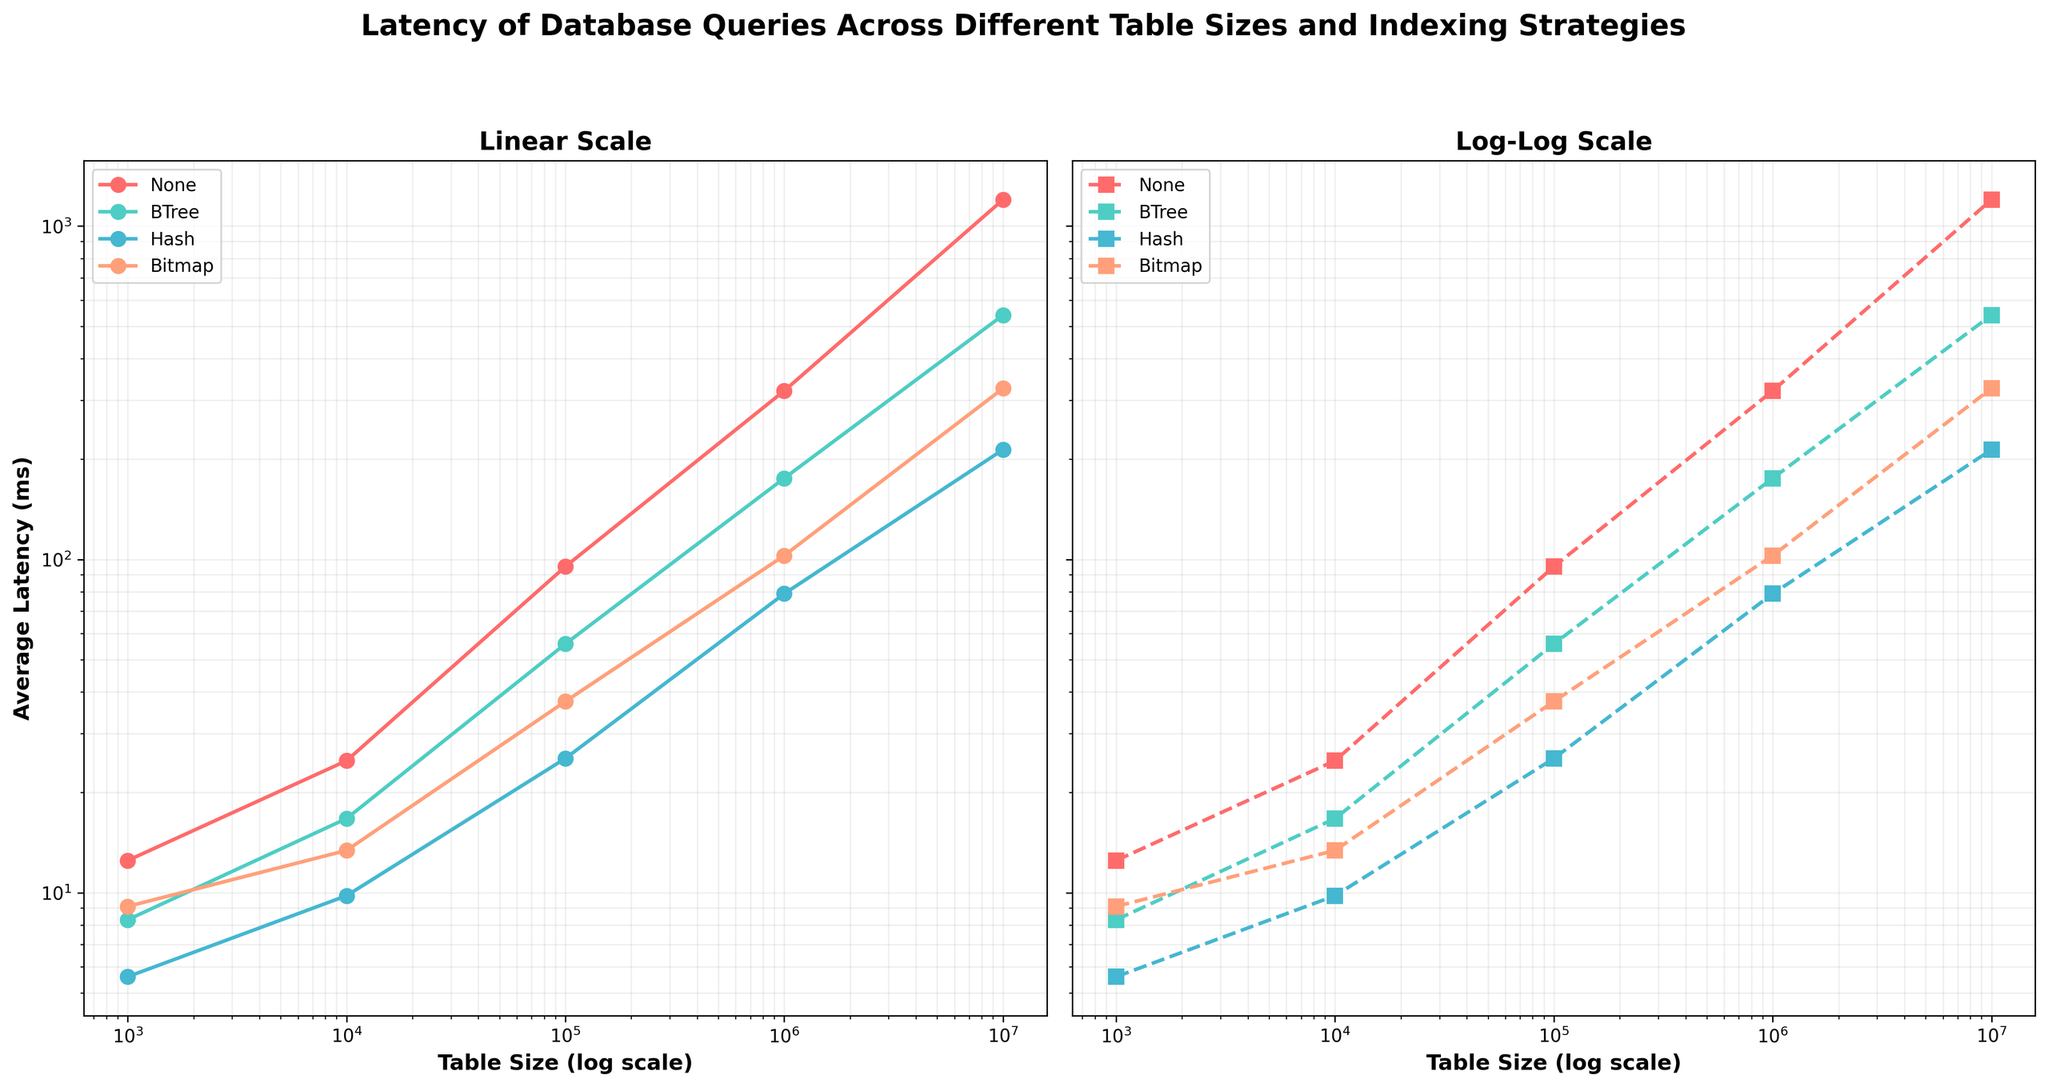What are the indexing strategies used in the figure? The figure's legend in both subplots lists the indexing strategies. These are None, BTree, Hash, and Bitmap.
Answer: None, BTree, Hash, Bitmap How does the latency of queries without indexing change as table size increases? The first subplot shows that the latency of queries with "None" indexing increases significantly as table size grows. It starts from 12.5 ms for table size 1000 and reaches 1200.4 ms for table size 10000000.
Answer: Increases significantly Which indexing strategy has the lowest latency for the largest table size? In the second subplot with log-log scale, the "Hash" indexing strategy shows the lowest latency for the largest table size (10,000,000) corresponding to an average latency of 213.5 ms.
Answer: Hash What is the difference in latency between BTree and Hash indexing strategies for a table size of 1,000,000? From the plots, the latency for BTree at 1,000,000 is 175.2 ms and for Hash is 78.9 ms. The difference is 175.2 - 78.9 = 96.3 ms.
Answer: 96.3 ms Which indexing strategy consistently shows a lower latency compared to Bitmap indexing for all table sizes? By comparing each point across the table sizes, "Hash" indexing consistently shows lower latency compared to "Bitmap" indexing across all table sizes.
Answer: Hash Is there a noticeable difference in trends between linear and log-log scale plots? Yes, while the linear scale shows the absolute value changes, the log-log scale provides a clearer view of the proportional differences and exponential growth patterns. Overall, the relative trends remain consistent, but the log-log scale elucidates exponential patterns.
Answer: Yes For a table size of 10,000, which strategy offers the most improvement over no indexing? For table size 10000, "None" indexing has a latency of 24.9 ms. "Hash" indexing has the lowest latency of 9.8 ms. The improvement is 24.9 - 9.8 = 15.1 ms.
Answer: Hash What can you infer about the effectiveness of the Bitmap strategy for large tables? The Bitmap indexing strategy has higher latencies compared to Hash and BTree strategies for larger table sizes (1,000,000 and 10,000,000). This suggests that Bitmap is less effective for very large tables.
Answer: Less effective How does the log scale affect the visualization of differences in latency across indexing strategies? The log scale in the x-axis (table size) and y-axis (latency) shrinks the distance between large values, making it easier to compare relative differences between strategies, especially for larger table sizes, illustrating proportional growth more clearly.
Answer: Easier comparison of proportional growth 